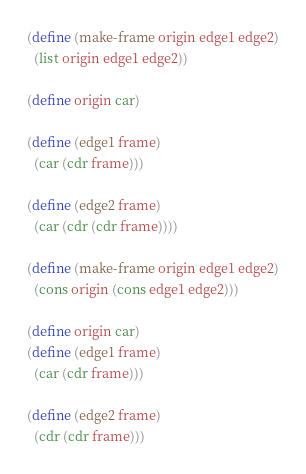Convert code to text. <code><loc_0><loc_0><loc_500><loc_500><_Scheme_>(define (make-frame origin edge1 edge2)
  (list origin edge1 edge2))

(define origin car)

(define (edge1 frame)
  (car (cdr frame)))

(define (edge2 frame)
  (car (cdr (cdr frame))))

(define (make-frame origin edge1 edge2)
  (cons origin (cons edge1 edge2)))

(define origin car)
(define (edge1 frame)
  (car (cdr frame)))

(define (edge2 frame)
  (cdr (cdr frame)))
</code> 